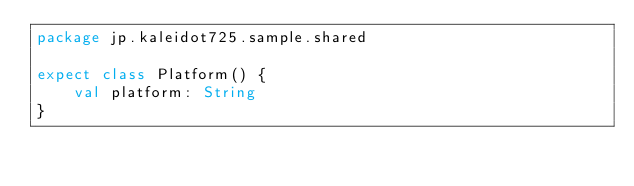Convert code to text. <code><loc_0><loc_0><loc_500><loc_500><_Kotlin_>package jp.kaleidot725.sample.shared

expect class Platform() {
    val platform: String
}</code> 